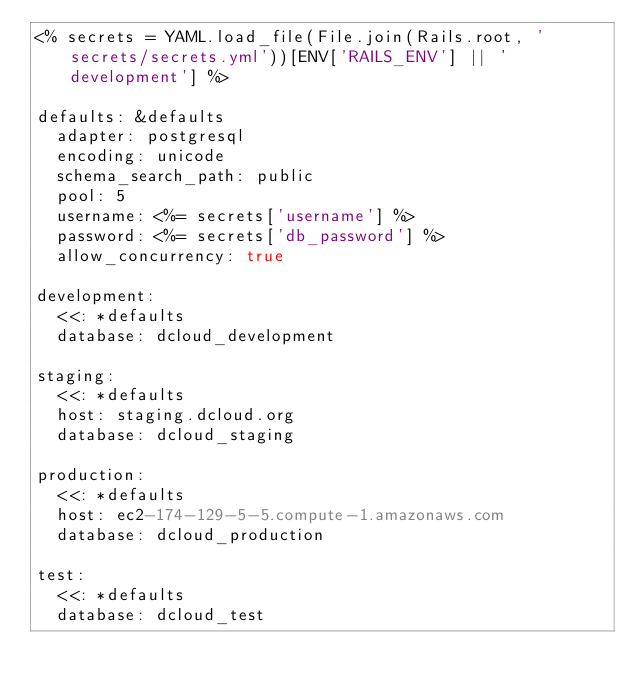Convert code to text. <code><loc_0><loc_0><loc_500><loc_500><_YAML_><% secrets = YAML.load_file(File.join(Rails.root, 'secrets/secrets.yml'))[ENV['RAILS_ENV'] || 'development'] %>

defaults: &defaults
  adapter: postgresql
  encoding: unicode
  schema_search_path: public
  pool: 5
  username: <%= secrets['username'] %>
  password: <%= secrets['db_password'] %>
  allow_concurrency: true

development:
  <<: *defaults
  database: dcloud_development

staging:
  <<: *defaults
  host: staging.dcloud.org
  database: dcloud_staging

production:
  <<: *defaults
  host: ec2-174-129-5-5.compute-1.amazonaws.com
  database: dcloud_production

test:
  <<: *defaults
  database: dcloud_test
</code> 